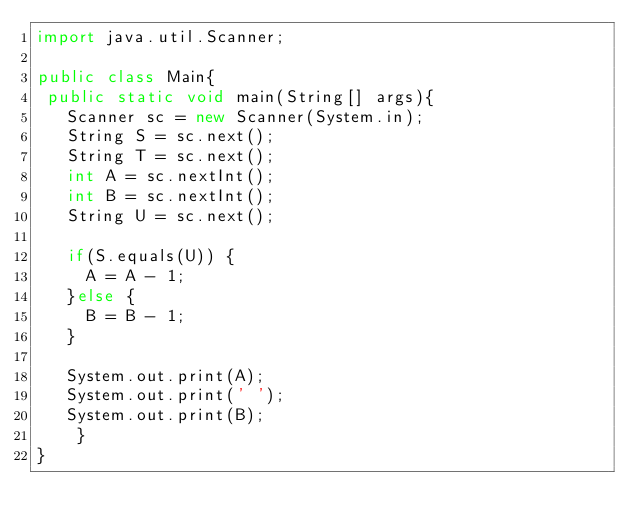Convert code to text. <code><loc_0><loc_0><loc_500><loc_500><_Java_>import java.util.Scanner;

public class Main{
 public static void main(String[] args){
   Scanner sc = new Scanner(System.in);
   String S = sc.next();
   String T = sc.next();
   int A = sc.nextInt();
   int B = sc.nextInt();
   String U = sc.next();

   if(S.equals(U)) {
	   A = A - 1;
   }else {
	   B = B - 1;
   }

   System.out.print(A);
   System.out.print(' ');
   System.out.print(B);
    }
}
</code> 